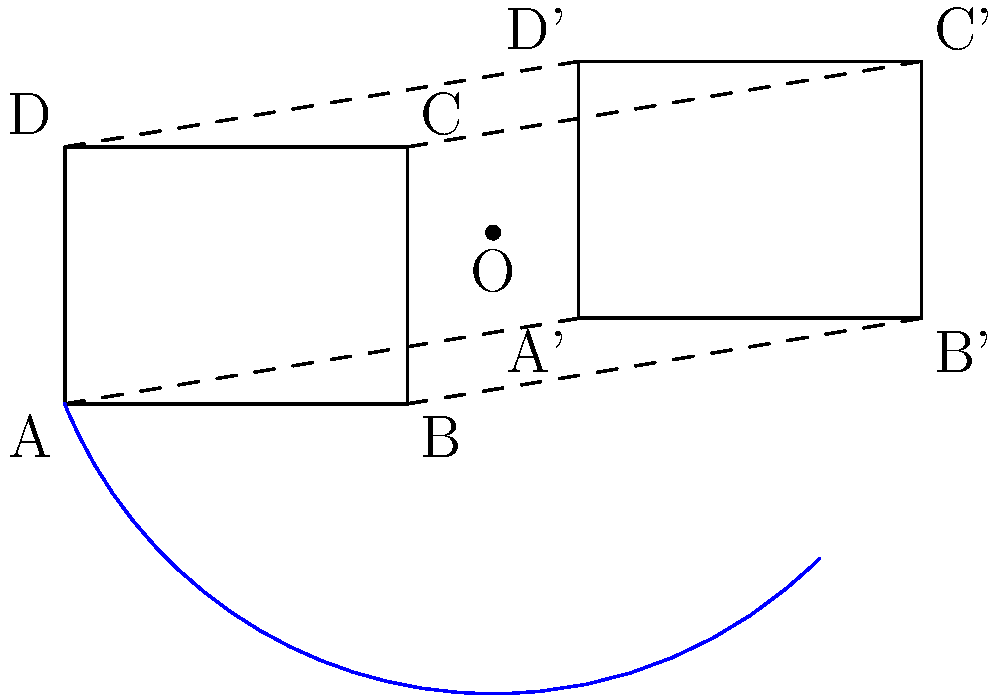Two similar protein molecule structures are represented by rectangles ABCD and A'B'C'D'. If the structures need to be aligned through a rotation around point O, what is the angle of rotation required? To determine the angle of rotation needed to align the two protein molecule structures, we can follow these steps:

1. Identify the center of rotation (O) and two corresponding points (A and A') on the structures.

2. Draw vectors OA and OA' from the center of rotation to these points.

3. The angle between these vectors is the required angle of rotation.

4. To calculate this angle, we can use the arctangent function:

   $$\theta = \arctan(\frac{y_{A'} - y_O}{x_{A'} - x_O}) - \arctan(\frac{y_A - y_O}{x_A - x_O})$$

5. From the diagram:
   O(5,2), A(0,0), A'(6,1)

6. Substituting these values:

   $$\theta = \arctan(\frac{1 - 2}{6 - 5}) - \arctan(\frac{0 - 2}{0 - 5})$$
   $$= \arctan(-1) - \arctan(\frac{2}{5})$$
   $$= -45° - 21.8°$$
   $$= -66.8°$$

7. The negative sign indicates a clockwise rotation. For a positive (counterclockwise) angle, we take the absolute value.

Therefore, the angle of rotation needed is approximately 66.8°.
Answer: 66.8° 